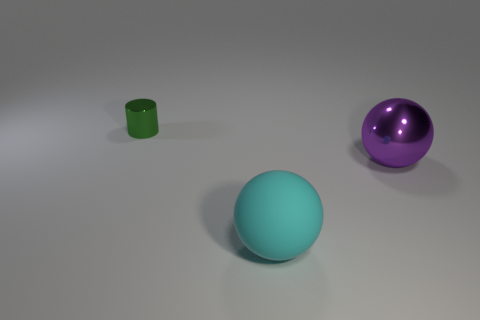Add 1 large rubber balls. How many objects exist? 4 Subtract all balls. How many objects are left? 1 Subtract all big purple shiny objects. Subtract all big purple spheres. How many objects are left? 1 Add 3 green things. How many green things are left? 4 Add 1 tiny brown things. How many tiny brown things exist? 1 Subtract 0 blue cubes. How many objects are left? 3 